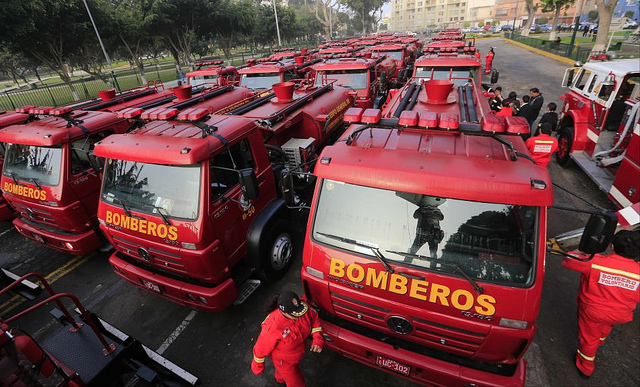Read and extract the text from this image. BOMBEROS BOMBEROS BOMBEROS 